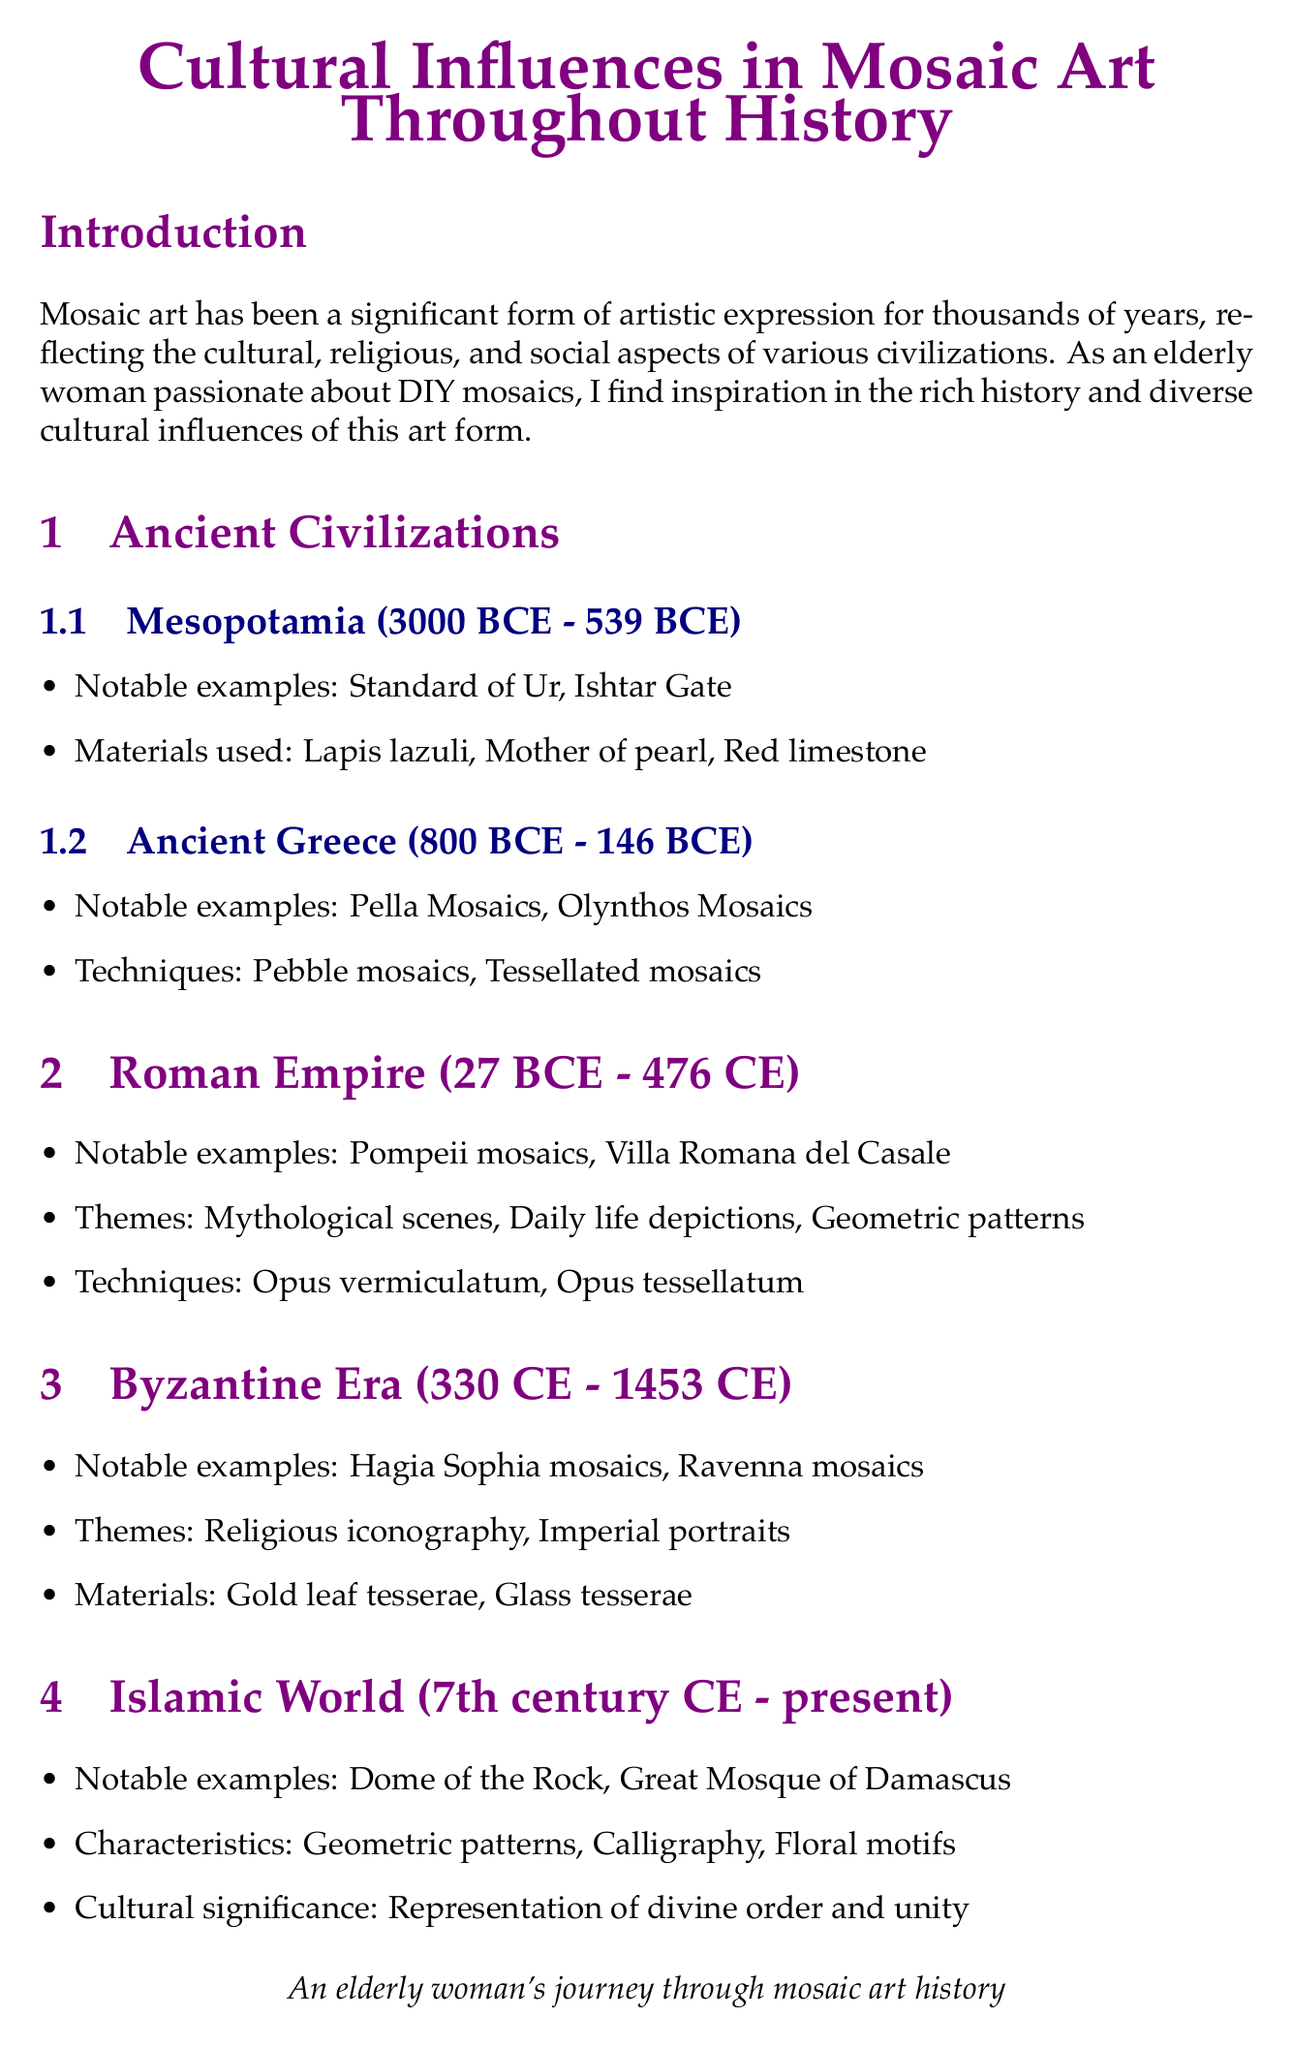what is the time period for Mesopotamia in mosaic art? The time period for Mesopotamia is stated in the document as 3000 BCE - 539 BCE.
Answer: 3000 BCE - 539 BCE which technique is used in Ancient Greece mosaics? The document lists techniques used in Ancient Greece mosaics, including pebble mosaics and tessellated mosaics.
Answer: Pebble mosaics what notable example is associated with the Roman Empire? Among the notable examples listed for the Roman Empire, the Pompeii mosaics are specifically mentioned.
Answer: Pompeii mosaics what material is used in Byzantine mosaics? The materials listed for Byzantine mosaics include gold leaf tesserae and glass tesserae.
Answer: Gold leaf tesserae which motifs are characteristic of Islamic mosaic art? The document mentions geometric patterns, calligraphy, and floral motifs as characteristics of Islamic mosaic art.
Answer: Geometric patterns how has modern mosaic art been applied today? The applications of modern mosaic art, as stated in the document, include public art installations, architectural decoration, and DIY home projects.
Answer: Public art installations what cultural significance do the mosaics of the Islamic world represent? The document describes the cultural significance of Islamic mosaics as representing divine order and unity.
Answer: Divine order and unity name a notable artist from the modern era of mosaic art. The document lists several notable artists from the modern era, including Antoni Gaudí.
Answer: Antoni Gaudí what is the overall theme of the conclusion in the document? The conclusion summarizes the journey through mosaic art history and highlights the interconnectedness of cultures.
Answer: Interconnectedness of cultures 